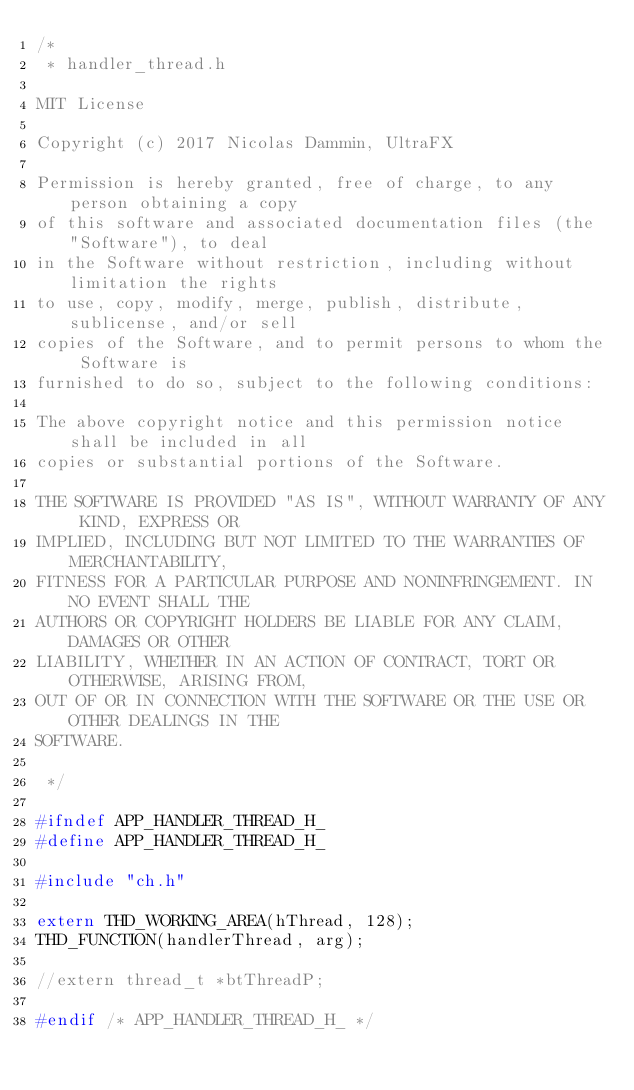Convert code to text. <code><loc_0><loc_0><loc_500><loc_500><_C_>/*
 * handler_thread.h

MIT License

Copyright (c) 2017 Nicolas Dammin, UltraFX

Permission is hereby granted, free of charge, to any person obtaining a copy
of this software and associated documentation files (the "Software"), to deal
in the Software without restriction, including without limitation the rights
to use, copy, modify, merge, publish, distribute, sublicense, and/or sell
copies of the Software, and to permit persons to whom the Software is
furnished to do so, subject to the following conditions:

The above copyright notice and this permission notice shall be included in all
copies or substantial portions of the Software.

THE SOFTWARE IS PROVIDED "AS IS", WITHOUT WARRANTY OF ANY KIND, EXPRESS OR
IMPLIED, INCLUDING BUT NOT LIMITED TO THE WARRANTIES OF MERCHANTABILITY,
FITNESS FOR A PARTICULAR PURPOSE AND NONINFRINGEMENT. IN NO EVENT SHALL THE
AUTHORS OR COPYRIGHT HOLDERS BE LIABLE FOR ANY CLAIM, DAMAGES OR OTHER
LIABILITY, WHETHER IN AN ACTION OF CONTRACT, TORT OR OTHERWISE, ARISING FROM,
OUT OF OR IN CONNECTION WITH THE SOFTWARE OR THE USE OR OTHER DEALINGS IN THE
SOFTWARE.

 */

#ifndef APP_HANDLER_THREAD_H_
#define APP_HANDLER_THREAD_H_

#include "ch.h"

extern THD_WORKING_AREA(hThread, 128);
THD_FUNCTION(handlerThread, arg);

//extern thread_t *btThreadP;

#endif /* APP_HANDLER_THREAD_H_ */
</code> 